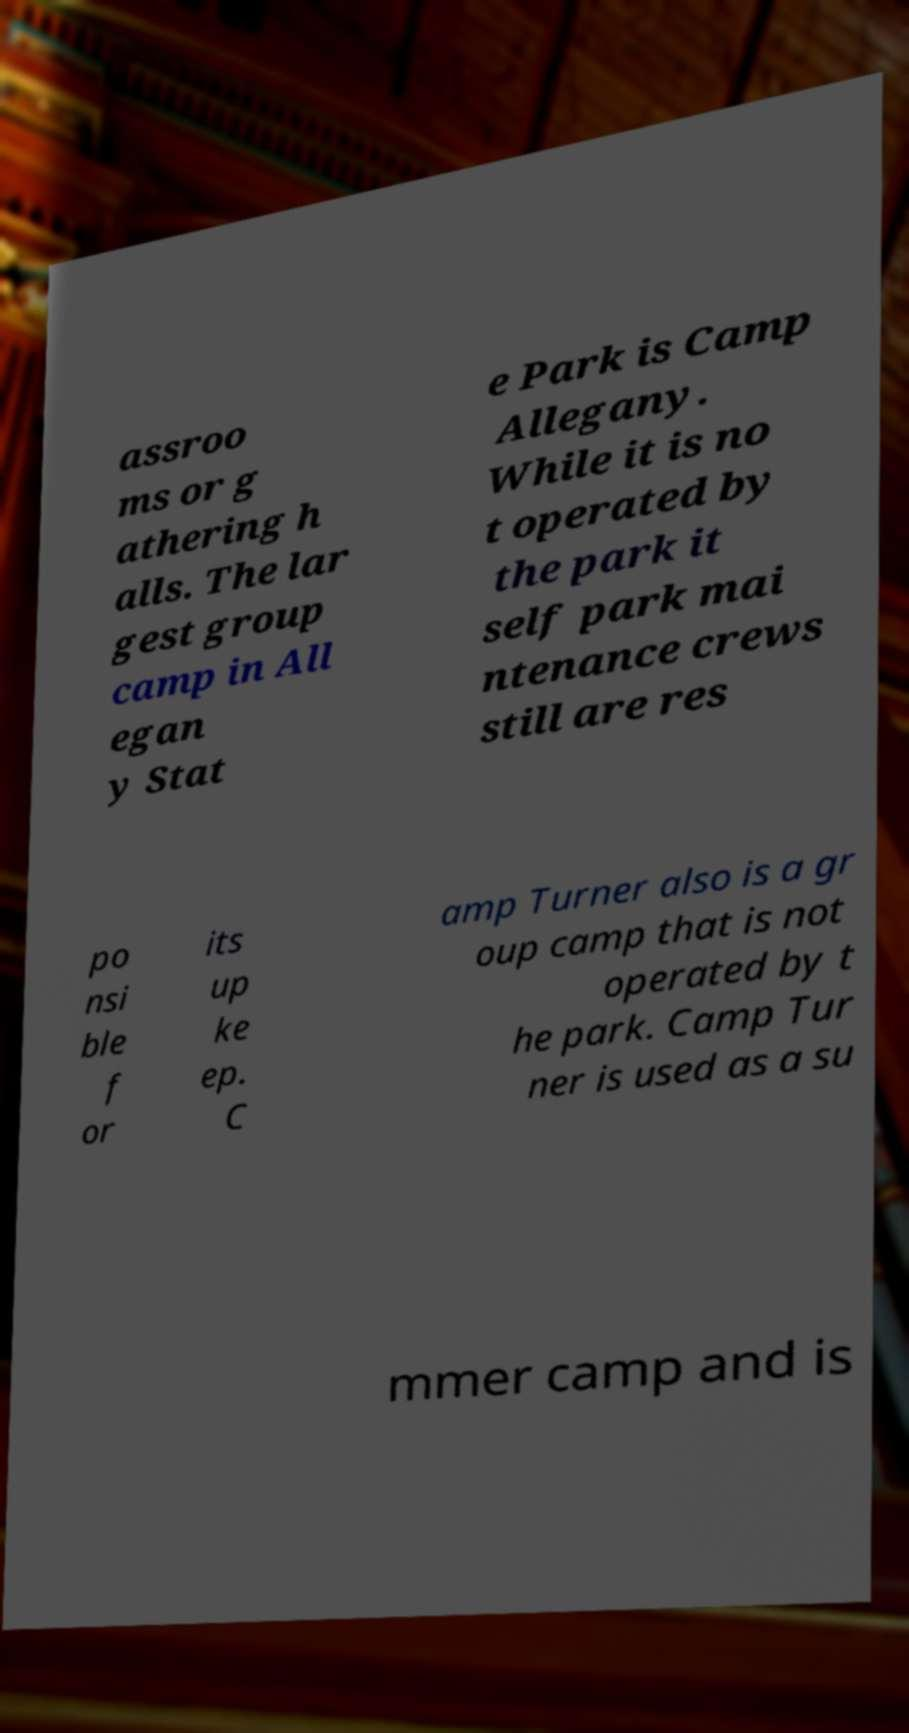Please identify and transcribe the text found in this image. assroo ms or g athering h alls. The lar gest group camp in All egan y Stat e Park is Camp Allegany. While it is no t operated by the park it self park mai ntenance crews still are res po nsi ble f or its up ke ep. C amp Turner also is a gr oup camp that is not operated by t he park. Camp Tur ner is used as a su mmer camp and is 